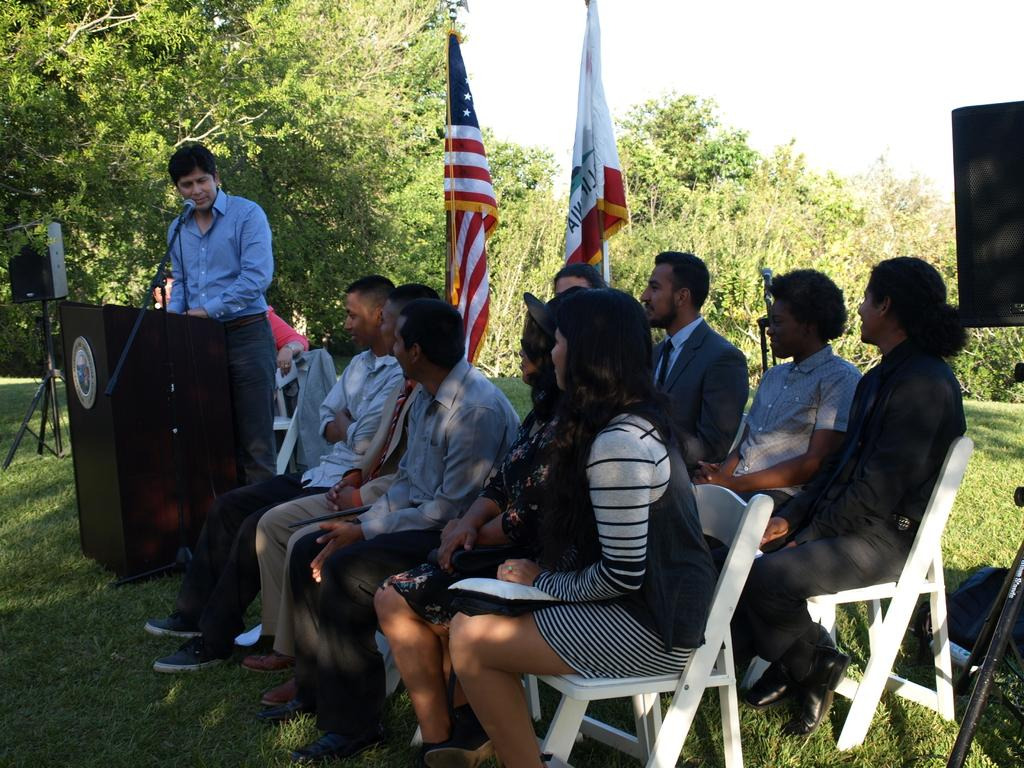How many people are in the image? There is a group of people in the image. What are the people in the image doing? The people are sitting. What can be seen in the image besides the group of people? There is a man standing at a podium in the image. What is the man at the podium doing? The man is speaking. What is the name of the country that the people in the image are from? The provided facts do not mention any specific country, so it cannot be determined from the image. 